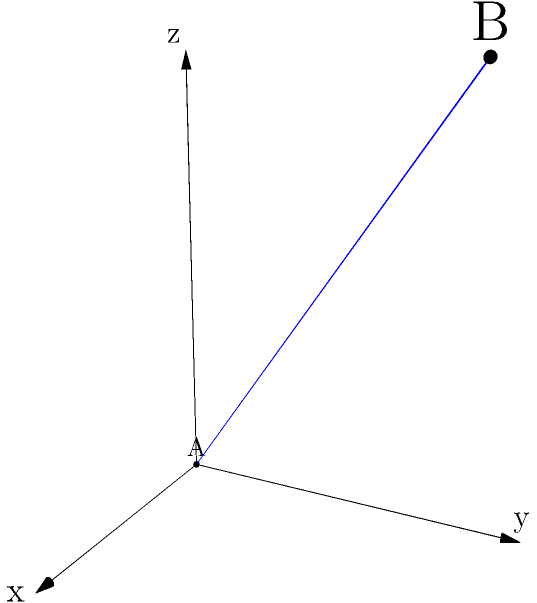In a 3D space, two data points A(0,0,0) and B(3,4,5) represent the extremes of a cluster in your dataset. Calculate the distance between these points. How might this unexpectedly large distance impact your clustering algorithm and potentially reveal unintended patterns in your data? To solve this problem, we'll follow these steps:

1) The distance between two points in 3D space is given by the formula:
   $$d = \sqrt{(x_2-x_1)^2 + (y_2-y_1)^2 + (z_2-z_1)^2}$$

2) We have:
   A(0,0,0) and B(3,4,5)
   So, $(x_2-x_1) = 3-0 = 3$
       $(y_2-y_1) = 4-0 = 4$
       $(z_2-z_1) = 5-0 = 5$

3) Plugging these into our formula:
   $$d = \sqrt{3^2 + 4^2 + 5^2}$$

4) Simplify:
   $$d = \sqrt{9 + 16 + 25} = \sqrt{50} = 5\sqrt{2} \approx 7.07$$

5) The distance between A and B is approximately 7.07 units.

6) This unexpectedly large distance might impact the clustering algorithm in several ways:

   a) It could lead to oversized clusters, potentially grouping together data points that should be in separate clusters.
   
   b) It might reveal that the dataset has a wider spread in 3D space than initially anticipated, suggesting the need for more nuanced clustering techniques.
   
   c) This could unintentionally highlight outliers or extreme values in the dataset that weren't previously considered significant.
   
   d) It might indicate that the chosen distance metric (Euclidean) is not appropriate for this dataset, and alternative metrics (e.g., Manhattan distance) should be considered.
   
   e) This large distance could skew distance-based algorithms, potentially leading to misinterpretation of data relationships and unintended consequences in decision-making processes based on these clusters.
Answer: Distance: $5\sqrt{2}$ units. Impacts: oversized clusters, wider data spread, highlight outliers, inappropriate distance metric, skewed algorithms. 